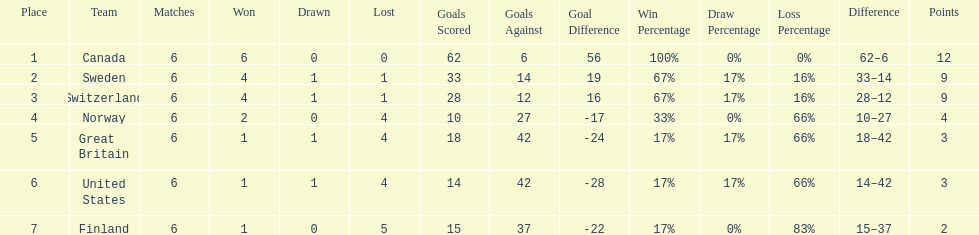What is the count of teams with 6 match wins? 1. 